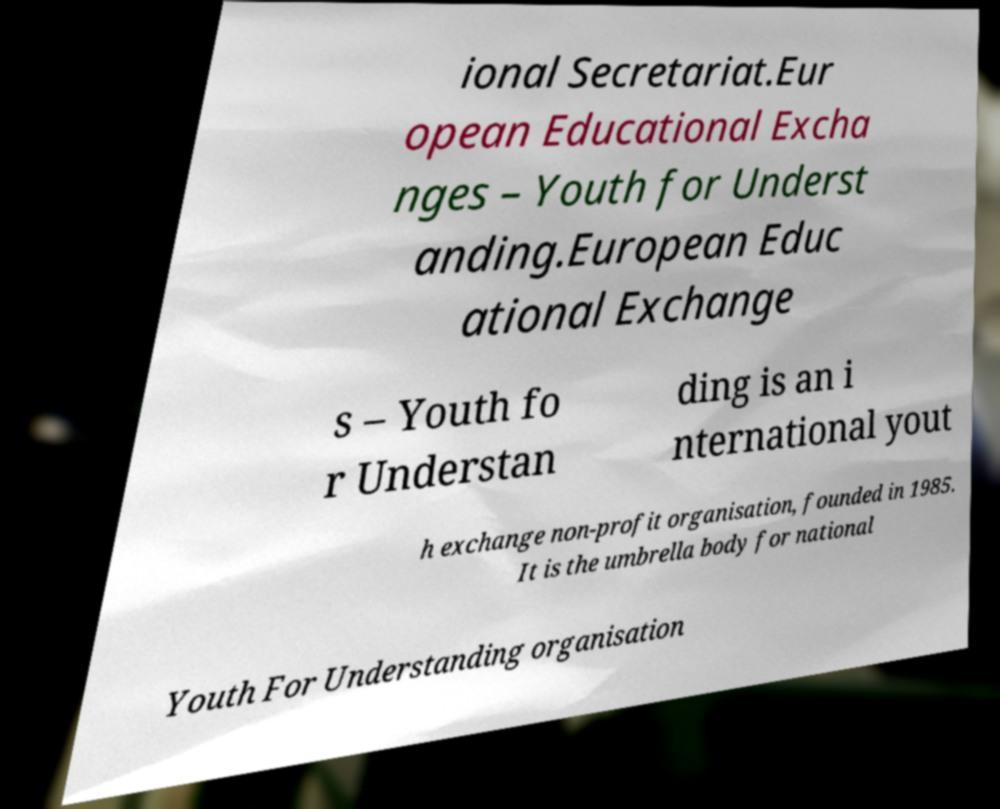Please identify and transcribe the text found in this image. ional Secretariat.Eur opean Educational Excha nges – Youth for Underst anding.European Educ ational Exchange s – Youth fo r Understan ding is an i nternational yout h exchange non-profit organisation, founded in 1985. It is the umbrella body for national Youth For Understanding organisation 